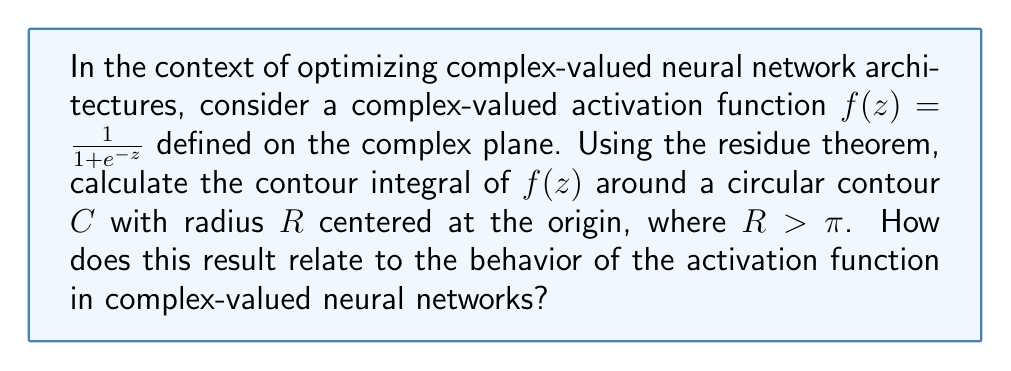Could you help me with this problem? To solve this problem, we'll follow these steps:

1) First, we need to identify the singularities of $f(z)$. The function $f(z) = \frac{1}{1+e^{-z}}$ has singularities when $1+e^{-z} = 0$, or when $e^{-z} = -1$.

2) Solving this, we get:
   $-z = \pi i + 2\pi i n$, where $n$ is any integer.
   $z = -\pi i - 2\pi i n$

3) The singularities are therefore at $z = \pi i, 3\pi i, 5\pi i, ...$ and $z = -\pi i, -3\pi i, -5\pi i, ...$

4) Given that the contour $C$ has radius $R > \pi$, it encloses only the singularities at $\pi i$ and $-\pi i$.

5) Now, let's calculate the residues at these points:

   At $z = \pi i$:
   $\text{Res}(f, \pi i) = \lim_{z \to \pi i} (z - \pi i)f(z) = \lim_{z \to \pi i} \frac{z - \pi i}{1+e^{-z}} = \frac{1}{-e^{-\pi i}} = -i$

   At $z = -\pi i$:
   $\text{Res}(f, -\pi i) = \lim_{z \to -\pi i} (z + \pi i)f(z) = \lim_{z \to -\pi i} \frac{z + \pi i}{1+e^{-z}} = \frac{1}{-e^{\pi i}} = i$

6) According to the residue theorem:
   $$\oint_C f(z) dz = 2\pi i \sum \text{Res}(f, a_k)$$
   where $a_k$ are the singularities enclosed by $C$.

7) Therefore:
   $$\oint_C f(z) dz = 2\pi i (-i + i) = 0$$

This result has important implications for complex-valued neural networks:

1) The zero contour integral indicates that the activation function $f(z)$ has a balanced behavior in the complex plane, which can help maintain stability during training.

2) The periodicity of the singularities (spaced at $2\pi i$ intervals) suggests that the function has a repeating pattern in the imaginary direction, which can be useful for processing periodic signals or data with cyclic patterns.

3) The symmetry of the residues ($i$ and $-i$) around the real axis implies that the function treats positive and negative imaginary inputs similarly, which can be beneficial for handling complex-valued data with phase information.
Answer: The contour integral of $f(z) = \frac{1}{1+e^{-z}}$ around the circular contour $C$ is zero: $$\oint_C f(z) dz = 0$$
This result indicates balanced behavior of the activation function in the complex plane, which can contribute to stability in complex-valued neural networks, handle periodic patterns, and process phase information effectively. 